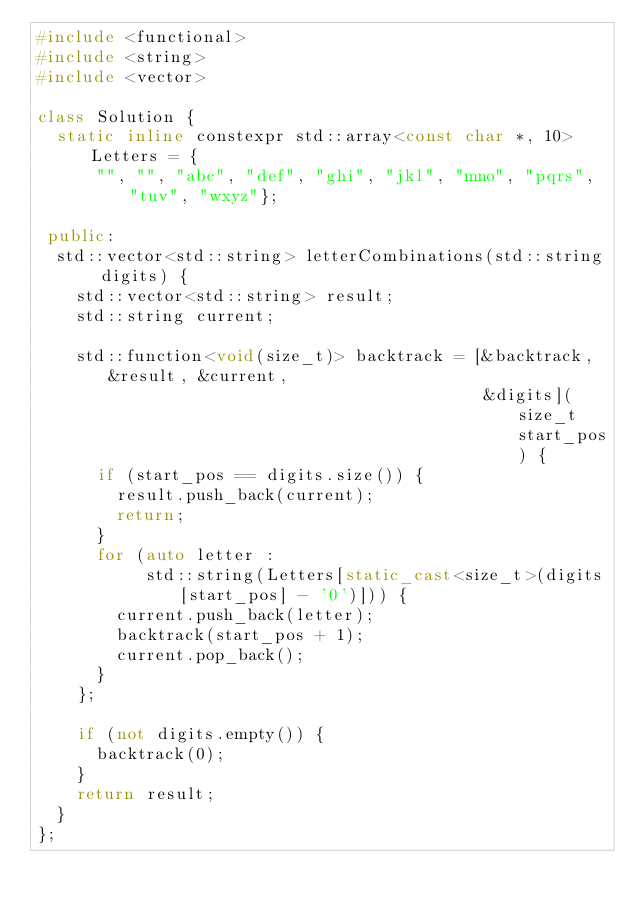Convert code to text. <code><loc_0><loc_0><loc_500><loc_500><_C++_>#include <functional>
#include <string>
#include <vector>

class Solution {
  static inline constexpr std::array<const char *, 10> Letters = {
      "", "", "abc", "def", "ghi", "jkl", "mno", "pqrs", "tuv", "wxyz"};

 public:
  std::vector<std::string> letterCombinations(std::string digits) {
    std::vector<std::string> result;
    std::string current;

    std::function<void(size_t)> backtrack = [&backtrack, &result, &current,
                                             &digits](size_t start_pos) {
      if (start_pos == digits.size()) {
        result.push_back(current);
        return;
      }
      for (auto letter :
           std::string(Letters[static_cast<size_t>(digits[start_pos] - '0')])) {
        current.push_back(letter);
        backtrack(start_pos + 1);
        current.pop_back();
      }
    };

    if (not digits.empty()) {
      backtrack(0);
    }
    return result;
  }
};
</code> 